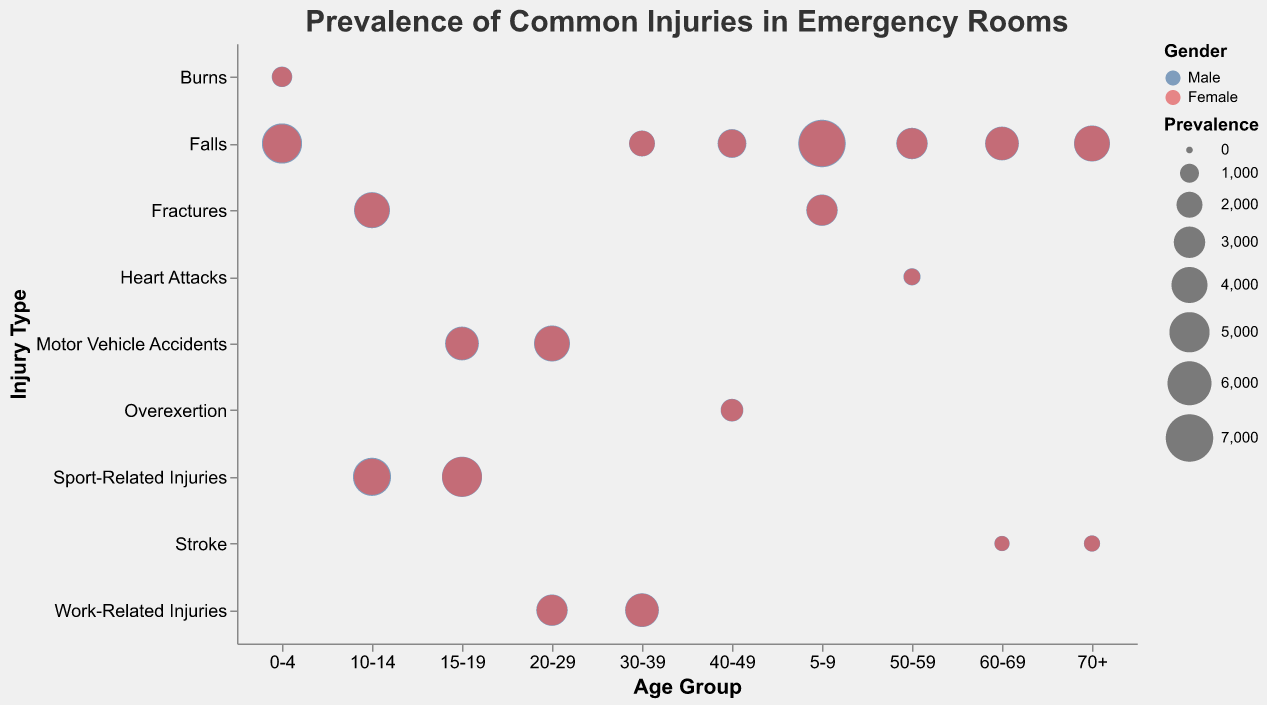What is the most common injury type for males aged 15-19? Observing the bubbles in the "15-19" Age Group column, the largest bubble for males is under "Sport-Related Injuries."
Answer: Sport-Related Injuries Which age group and gender has the highest prevalence of falls? Looking at all the bubbles that represent "Falls" across different age groups, the largest one is in the "0-4" Age Group for males with a prevalence of 5000.
Answer: Males aged 0-4 What is the prevalence difference of fractures between males and females aged 10-14? In the "10-14" Age Group row, the prevalence for males is 4000 and for females is 3700. The difference is 4000 - 3700.
Answer: 300 Which injury type appears most for females across all age groups? By scanning the bubbles colored for females across all rows, "Falls" appear the most frequently.
Answer: Falls Among severe injuries, which age group shows the highest prevalence for females? Observing the size of bubbles shaped as triangles (severe) for females, the largest one is in the "70+" Age Group for Falls with a prevalence of 3800.
Answer: 70+ How does the prevalence of motor vehicle accidents in males compare across the 15-19 and 20-29 age groups? The prevalence of motor vehicle accidents for males is 3500 in the "15-19" Age Group and 4000 in the "20-29" Age Group. Comparing these, 4000 is greater than 3500.
Answer: Higher in 20-29 Which injury type has the smallest prevalence for females aged 40-49? In the "40-49" Age Group row for females, the smallest bubble corresponds to "Overexertion" with a prevalence of 1400.
Answer: Overexertion Do males or females have a higher prevalence of heart attacks in the 50-59 age range? Checking the "Heart Attacks" bubbles in the "50-59" Age Group, males have a prevalence of 800 while females have 700. Comparing these, 800 is greater than 700.
Answer: Males What is the average prevalence of falls across all age groups for males? Summing the prevalence of falls for males across all ages: 5000 + 7000 + 2000 + 2500 + 3000 + 3500 + 4000 = 27000. There are 7 age groups, so the average is 27000 / 7.
Answer: 3857.1 